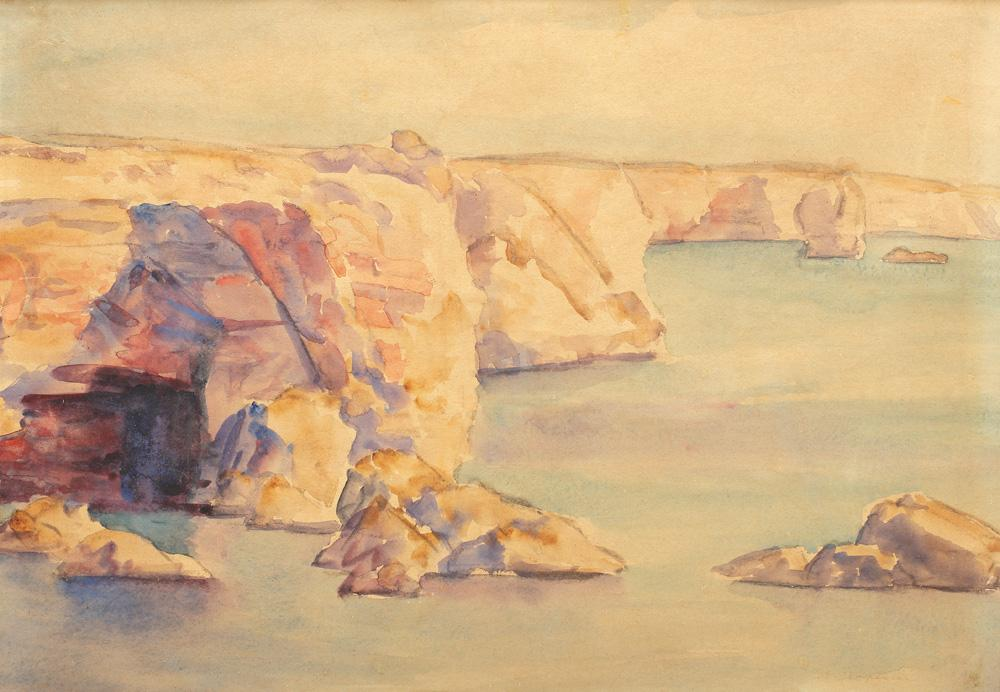Describe the following image. The image displays a watercolor painting that skillfully captures a rocky, sunlit coastline. The artist's choice of a loose, impressionistic style conveys not just the physical landscape but also an ethereal quality, making the scenery seem almost dreamlike. The palette incorporates a blend of warm tones, featuring yellows, oranges, and muted reds that suggest sunlight dappling over the rocks, contrasting with the serene blue and green hues of the tranquil sea. This painting might belong to the landscape genre, characterized by an emphasis on the beauty and subtlety of natural forms. Notably, the painter's adept use of watercolors creates a vibrant interplay of lights and shadows, bringing depth and movement to the serene seascape, making it a profound reflection on natural beauty. 